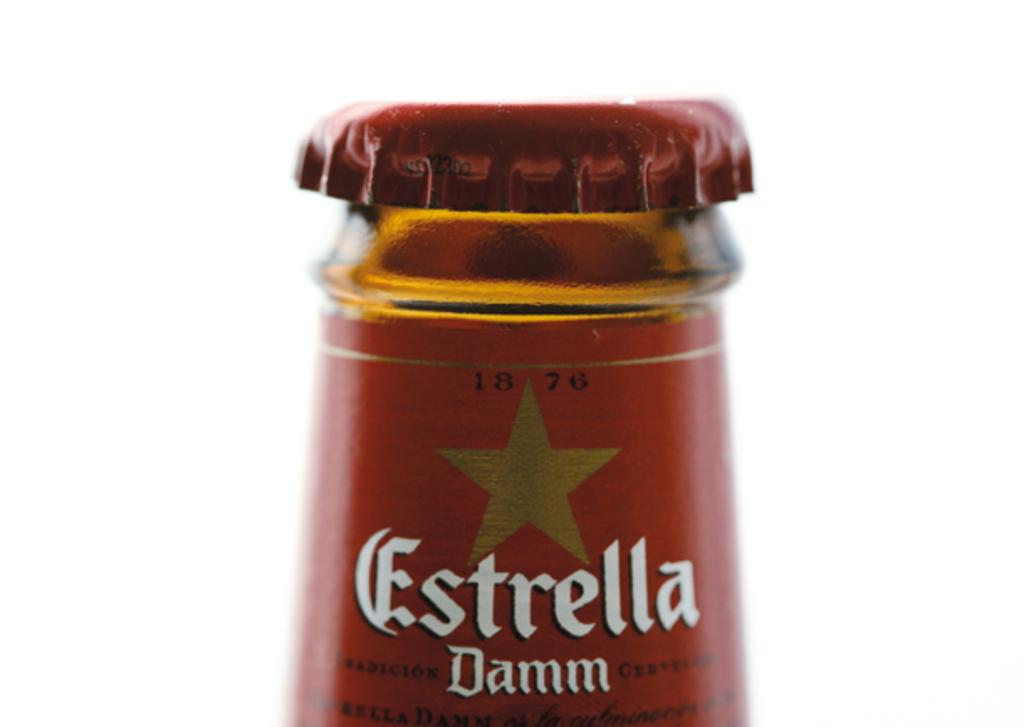What kind of beer is this?
Ensure brevity in your answer.  Estrella. What year is on the bottle?
Provide a short and direct response. 1876. 